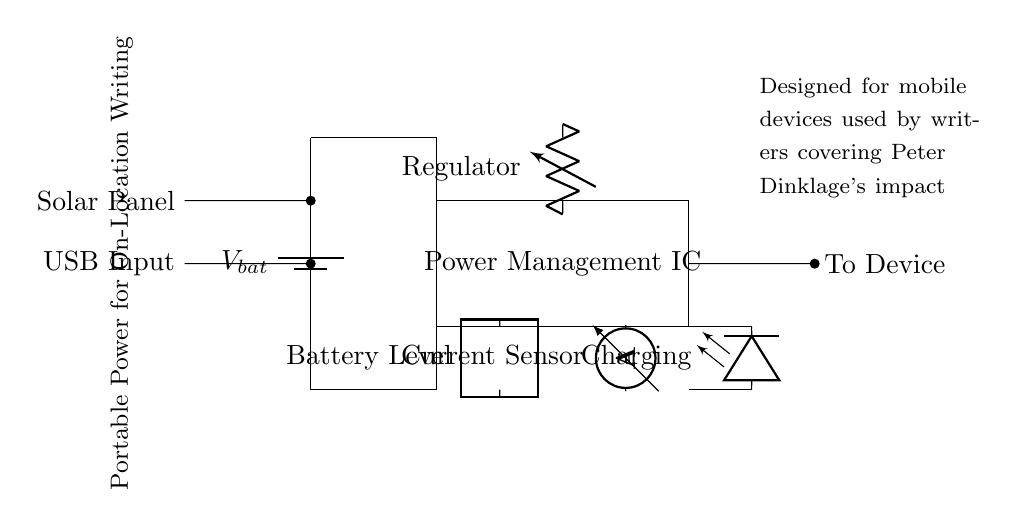What does the battery provide? The battery provides voltage to the circuit. This is indicated by the battery symbol in the upper left of the diagram labeled with "V bat," which represents the voltage supply.
Answer: Voltage What is the purpose of the power management IC? The power management IC regulates power distribution in the circuit. It is represented as a rectangle in the center of the diagram, which indicates it is a critical component responsible for managing the voltage and current supplied to the connected devices.
Answer: Regulates power distribution What type of input can be used to charge the battery? The battery can be charged using a solar panel or a USB input. Both inputs are shown in the circuit diagram, where the solar panel input is connected above the USB input to the battery.
Answer: Solar panel, USB input What does the current sensor measure? The current sensor measures the amount of current flowing to or from the battery. In the circuit diagram, the current sensor is depicted as an ammeter connected to the circuit, highlighting its function to monitor current levels.
Answer: Current What does the charging indicator LED signify? The charging indicator LED signifies that the battery is charging when power is supplied from either the solar panel or USB input. In the diagram, the LED is shown with an associated label indicating its purpose when connected to the circuit.
Answer: Charging What does the battery level indicator show? The battery level indicator shows the current charge level of the battery, allowing users to determine how much power is left. The circuit diagram includes a label indicating this function next to the two-port component.
Answer: Battery level 